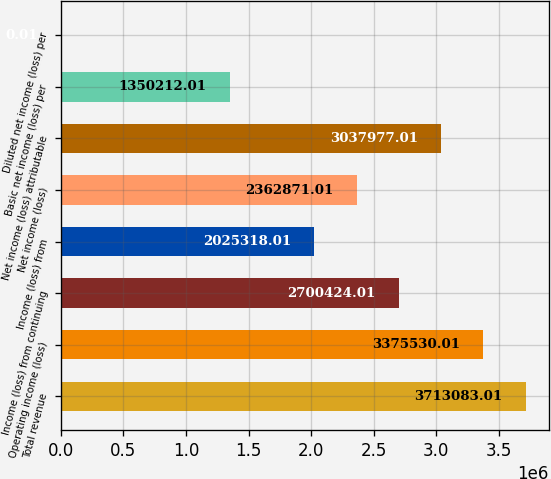Convert chart. <chart><loc_0><loc_0><loc_500><loc_500><bar_chart><fcel>Total revenue<fcel>Operating income (loss)<fcel>Income (loss) from continuing<fcel>Income (loss) from<fcel>Net income (loss)<fcel>Net income (loss) attributable<fcel>Basic net income (loss) per<fcel>Diluted net income (loss) per<nl><fcel>3.71308e+06<fcel>3.37553e+06<fcel>2.70042e+06<fcel>2.02532e+06<fcel>2.36287e+06<fcel>3.03798e+06<fcel>1.35021e+06<fcel>0.01<nl></chart> 